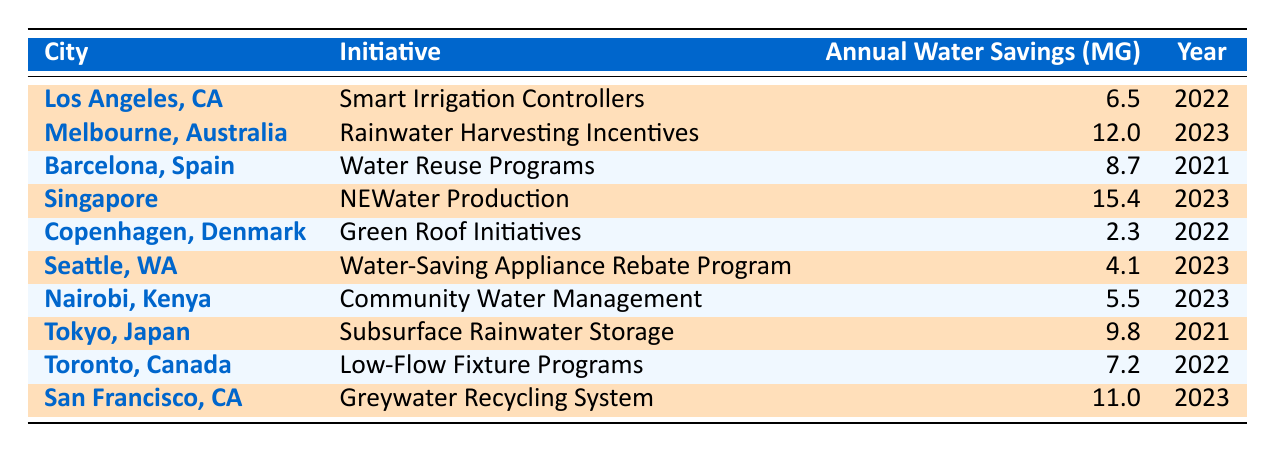What city implemented the "Greywater Recycling System"? The table shows that the "Greywater Recycling System" is implemented in "San Francisco, CA". By looking at the "Initiative" column, I find that the relevant city is listed alongside its initiative.
Answer: San Francisco, CA How much annual water savings does Singapore's initiative provide? Referring to the table, the "Annual Water Savings" for Singapore's "NEWater Production" initiative is listed as 15.4 million gallons.
Answer: 15.4 million gallons Which two cities have highlighted initiatives that were implemented in 2023? By checking the "Implementation Year" column, I can see that both "Melbourne, Australia" (Rainwater Harvesting Incentives) and "Singapore" (NEWater Production) have highlighted initiatives listed as implemented in 2023.
Answer: Melbourne, Australia and Singapore What is the total annual water savings from the highlighted initiatives? To find the total, I add the annual water savings of all highlighted initiatives: 6.5 (Los Angeles) + 12.0 (Melbourne) + 15.4 (Singapore) + 4.1 (Seattle) + 9.8 (Tokyo) + 11.0 (San Francisco) = 58.8 million gallons.
Answer: 58.8 million gallons Is it true that Copenhagen's initiative provides more annual water savings than Nairobi's? By comparing the "Annual Water Savings," Copenhagen's "Green Roof Initiatives" provides 2.3 million gallons, while Nairobi's "Community Water Management" provides 5.5 million gallons. Since 2.3 is less than 5.5, the statement is false.
Answer: False Which highlighted initiative has the highest annual water savings, and which city is it associated with? Looking at the table, I can see that Singapore's "NEWater Production" has the highest annual water savings at 15.4 million gallons.
Answer: NEWater Production, Singapore How do the annual water savings of Seattle's initiative compare to that of Barcelona's? Seattle's "Water-Saving Appliance Rebate Program" saves 4.1 million gallons, while Barcelona's "Water Reuse Programs" saves 8.7 million gallons. Therefore, Barcelona's initiative provides 4.6 million gallons more.
Answer: Seattle saves less by 4.6 million gallons Which city's initiative has the least annual water savings, and what is that savings? The table indicates that Copenhagen's "Green Roof Initiatives" has the least annual water savings at 2.3 million gallons.
Answer: Copenhagen, 2.3 million gallons List all cities that have highlighted initiatives that save more than 10 million gallons of water annually. Referring to the "Annual Water Savings," I see that Melbourne (12.0 million), Singapore (15.4 million), and San Francisco (11.0 million) all have savings above 10 million gallons.
Answer: Melbourne, Singapore, San Francisco 